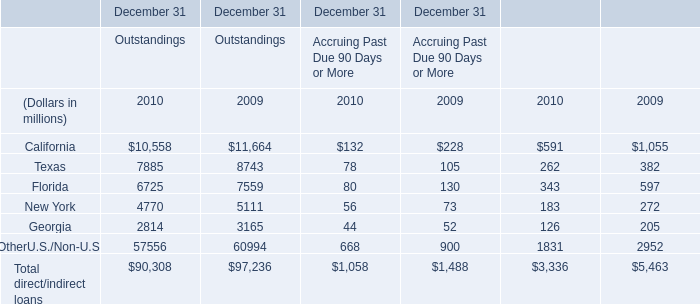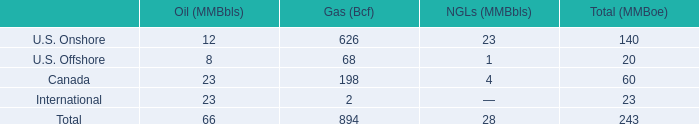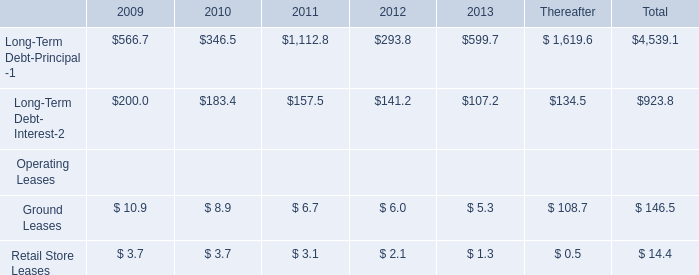What will total direct/indirect loans of Outstandings reach in 2011 if it continues to grow at its current rate? (in dollars in millions) 
Computations: (90308 * (1 + ((90308 - 97236) / 97236)))
Answer: 83873.61537. 